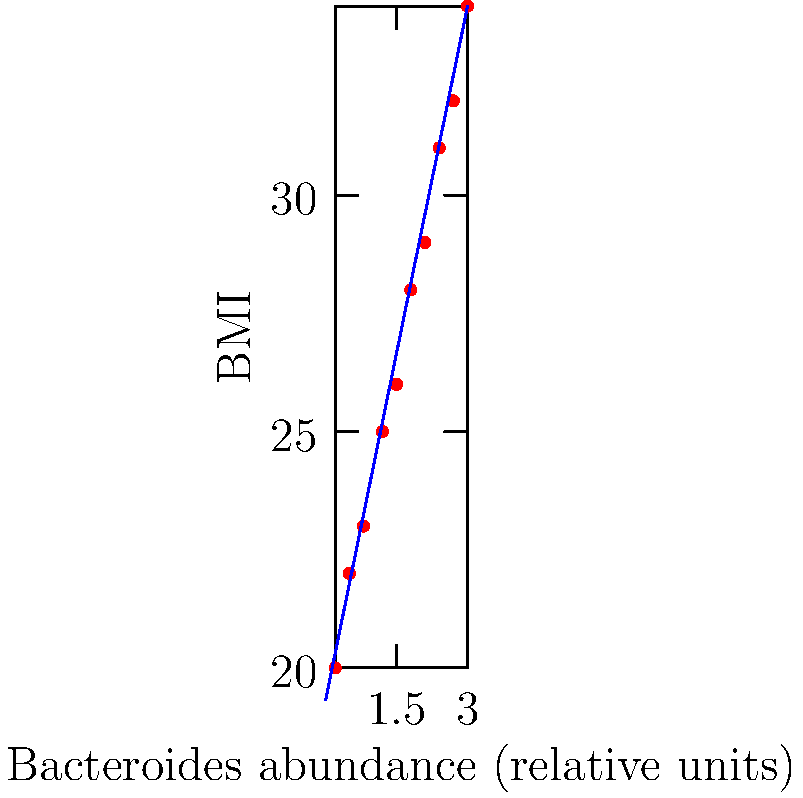Based on the scatter plot showing the relationship between Bacteroides abundance and BMI, what can be inferred about the correlation between these two variables? To analyze the correlation between Bacteroides abundance and BMI, we need to follow these steps:

1. Observe the overall pattern of the data points:
   The points seem to follow an upward trend from left to right.

2. Assess the strength of the relationship:
   The points are relatively close to a straight line, indicating a moderately strong relationship.

3. Determine the direction of the correlation:
   As Bacteroides abundance increases, BMI also tends to increase, suggesting a positive correlation.

4. Look at the trend line:
   The blue line represents the best-fit linear trend, which has a positive slope, confirming the positive correlation.

5. Consider the spread of the data points:
   There is some scatter around the trend line, but it's not excessive, indicating a fairly consistent relationship.

6. Quantify the relationship:
   While we don't have the exact correlation coefficient, the visual representation suggests a moderate to strong positive correlation.

7. Interpret in the context of microbiome research:
   This data suggests that higher abundance of Bacteroides species in the gut microbiome is associated with higher BMI values.

Based on these observations, we can conclude that there is a positive correlation between Bacteroides abundance and BMI, with higher Bacteroides levels generally corresponding to higher BMI values.
Answer: Positive correlation 